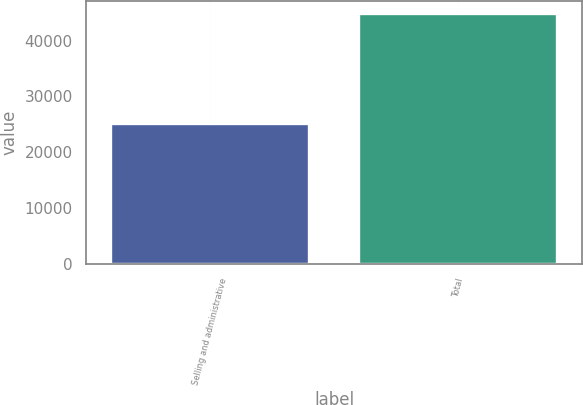Convert chart. <chart><loc_0><loc_0><loc_500><loc_500><bar_chart><fcel>Selling and administrative<fcel>Total<nl><fcel>25118<fcel>44808<nl></chart> 